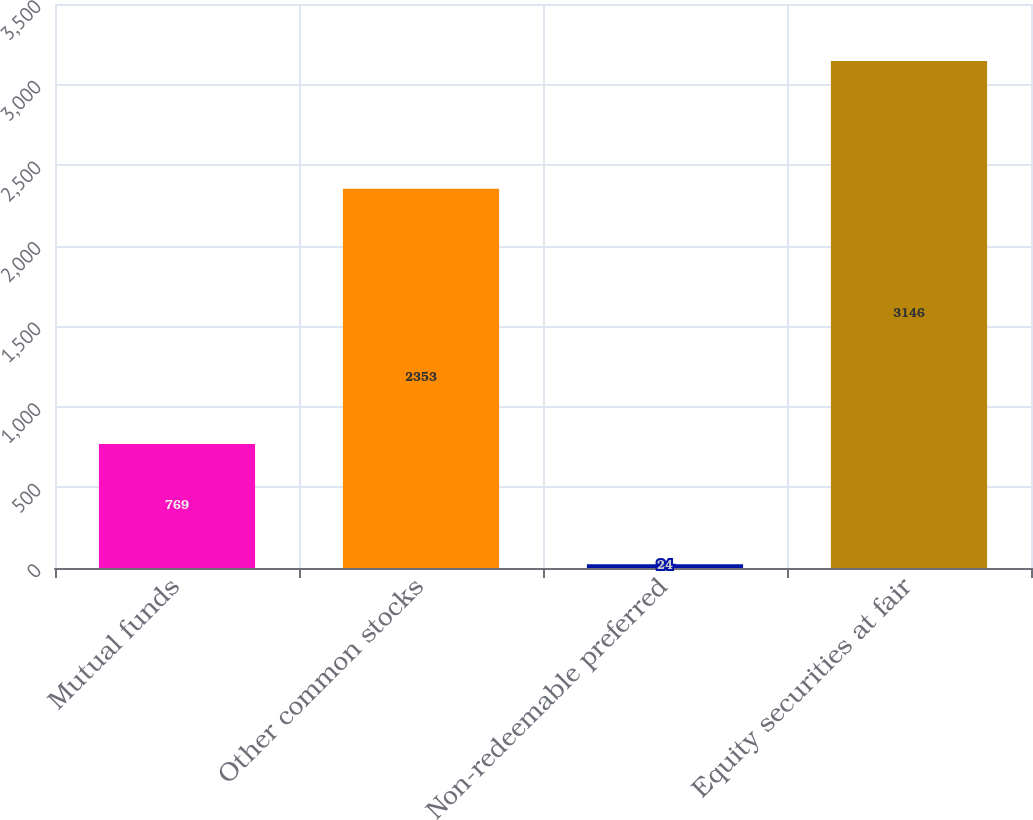Convert chart to OTSL. <chart><loc_0><loc_0><loc_500><loc_500><bar_chart><fcel>Mutual funds<fcel>Other common stocks<fcel>Non-redeemable preferred<fcel>Equity securities at fair<nl><fcel>769<fcel>2353<fcel>24<fcel>3146<nl></chart> 